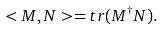<formula> <loc_0><loc_0><loc_500><loc_500>< M , N > = t r ( M ^ { \dagger } N ) .</formula> 